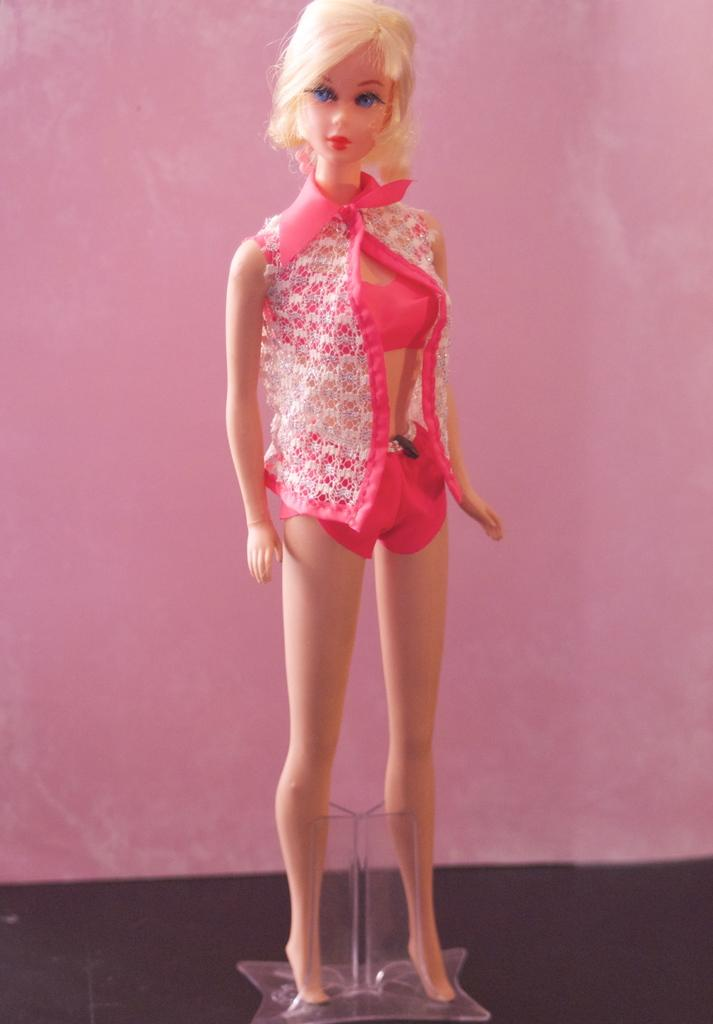What is the main subject in the center of the image? There is a toy in the center of the image. What can be seen in the background of the image? There is a wall in the background of the image. What is located at the bottom of the image? There is a glass box at the bottom of the image. Can you hear the toy making any sounds in the image? The image does not provide any information about sounds or the toy making any sounds. 